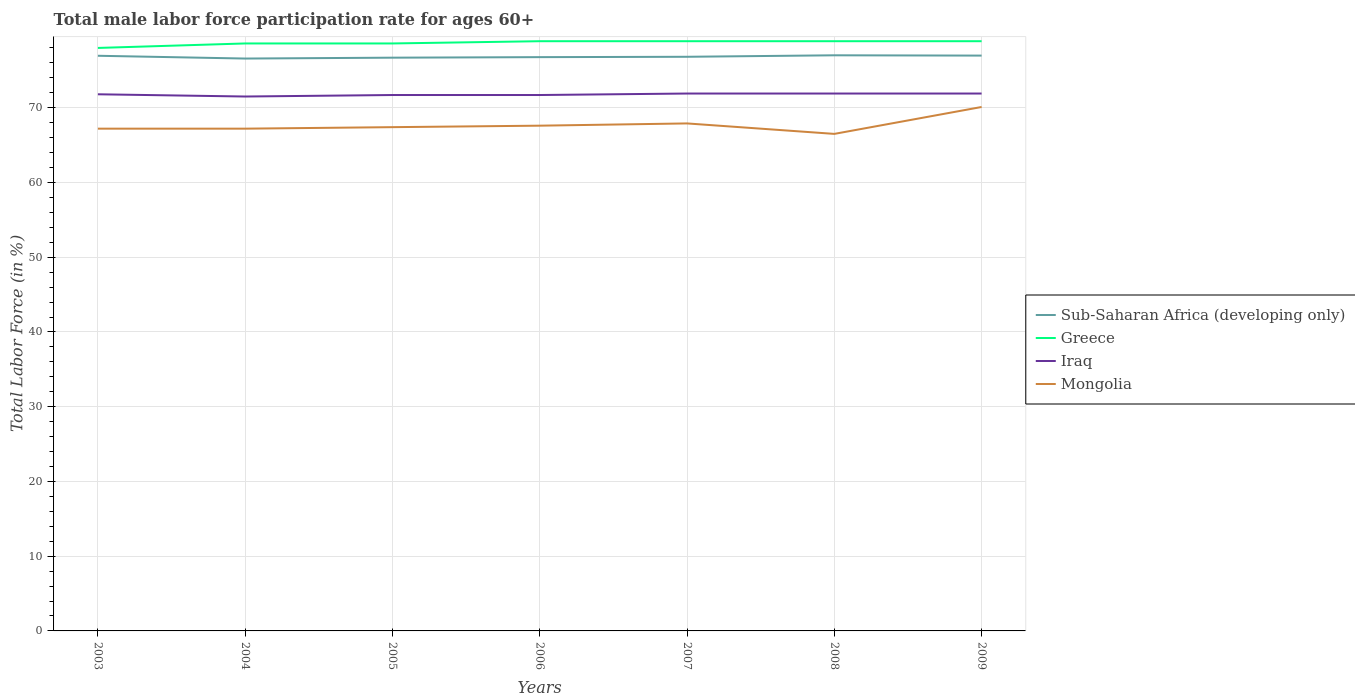How many different coloured lines are there?
Ensure brevity in your answer.  4. Is the number of lines equal to the number of legend labels?
Give a very brief answer. Yes. Across all years, what is the maximum male labor force participation rate in Greece?
Offer a terse response. 78. What is the difference between the highest and the second highest male labor force participation rate in Greece?
Your response must be concise. 0.9. How many lines are there?
Your response must be concise. 4. How many years are there in the graph?
Offer a very short reply. 7. Are the values on the major ticks of Y-axis written in scientific E-notation?
Provide a short and direct response. No. Where does the legend appear in the graph?
Offer a terse response. Center right. What is the title of the graph?
Give a very brief answer. Total male labor force participation rate for ages 60+. What is the label or title of the X-axis?
Give a very brief answer. Years. What is the Total Labor Force (in %) of Sub-Saharan Africa (developing only) in 2003?
Offer a terse response. 76.95. What is the Total Labor Force (in %) in Greece in 2003?
Your answer should be compact. 78. What is the Total Labor Force (in %) in Iraq in 2003?
Keep it short and to the point. 71.8. What is the Total Labor Force (in %) of Mongolia in 2003?
Ensure brevity in your answer.  67.2. What is the Total Labor Force (in %) of Sub-Saharan Africa (developing only) in 2004?
Your answer should be very brief. 76.58. What is the Total Labor Force (in %) of Greece in 2004?
Offer a very short reply. 78.6. What is the Total Labor Force (in %) in Iraq in 2004?
Ensure brevity in your answer.  71.5. What is the Total Labor Force (in %) in Mongolia in 2004?
Provide a succinct answer. 67.2. What is the Total Labor Force (in %) of Sub-Saharan Africa (developing only) in 2005?
Your answer should be very brief. 76.7. What is the Total Labor Force (in %) of Greece in 2005?
Your answer should be compact. 78.6. What is the Total Labor Force (in %) of Iraq in 2005?
Give a very brief answer. 71.7. What is the Total Labor Force (in %) in Mongolia in 2005?
Provide a short and direct response. 67.4. What is the Total Labor Force (in %) of Sub-Saharan Africa (developing only) in 2006?
Provide a short and direct response. 76.77. What is the Total Labor Force (in %) in Greece in 2006?
Your response must be concise. 78.9. What is the Total Labor Force (in %) of Iraq in 2006?
Your answer should be very brief. 71.7. What is the Total Labor Force (in %) in Mongolia in 2006?
Provide a short and direct response. 67.6. What is the Total Labor Force (in %) of Sub-Saharan Africa (developing only) in 2007?
Offer a very short reply. 76.82. What is the Total Labor Force (in %) in Greece in 2007?
Your response must be concise. 78.9. What is the Total Labor Force (in %) in Iraq in 2007?
Your answer should be compact. 71.9. What is the Total Labor Force (in %) in Mongolia in 2007?
Provide a short and direct response. 67.9. What is the Total Labor Force (in %) of Sub-Saharan Africa (developing only) in 2008?
Provide a succinct answer. 77.01. What is the Total Labor Force (in %) in Greece in 2008?
Ensure brevity in your answer.  78.9. What is the Total Labor Force (in %) of Iraq in 2008?
Ensure brevity in your answer.  71.9. What is the Total Labor Force (in %) in Mongolia in 2008?
Your answer should be very brief. 66.5. What is the Total Labor Force (in %) of Sub-Saharan Africa (developing only) in 2009?
Provide a succinct answer. 76.98. What is the Total Labor Force (in %) in Greece in 2009?
Keep it short and to the point. 78.9. What is the Total Labor Force (in %) of Iraq in 2009?
Offer a terse response. 71.9. What is the Total Labor Force (in %) of Mongolia in 2009?
Your response must be concise. 70.1. Across all years, what is the maximum Total Labor Force (in %) in Sub-Saharan Africa (developing only)?
Make the answer very short. 77.01. Across all years, what is the maximum Total Labor Force (in %) of Greece?
Your response must be concise. 78.9. Across all years, what is the maximum Total Labor Force (in %) in Iraq?
Your response must be concise. 71.9. Across all years, what is the maximum Total Labor Force (in %) in Mongolia?
Give a very brief answer. 70.1. Across all years, what is the minimum Total Labor Force (in %) of Sub-Saharan Africa (developing only)?
Provide a succinct answer. 76.58. Across all years, what is the minimum Total Labor Force (in %) in Iraq?
Your response must be concise. 71.5. Across all years, what is the minimum Total Labor Force (in %) of Mongolia?
Offer a terse response. 66.5. What is the total Total Labor Force (in %) in Sub-Saharan Africa (developing only) in the graph?
Your response must be concise. 537.81. What is the total Total Labor Force (in %) of Greece in the graph?
Your answer should be compact. 550.8. What is the total Total Labor Force (in %) in Iraq in the graph?
Provide a succinct answer. 502.4. What is the total Total Labor Force (in %) in Mongolia in the graph?
Provide a short and direct response. 473.9. What is the difference between the Total Labor Force (in %) in Sub-Saharan Africa (developing only) in 2003 and that in 2004?
Make the answer very short. 0.37. What is the difference between the Total Labor Force (in %) of Greece in 2003 and that in 2004?
Give a very brief answer. -0.6. What is the difference between the Total Labor Force (in %) of Iraq in 2003 and that in 2004?
Keep it short and to the point. 0.3. What is the difference between the Total Labor Force (in %) of Sub-Saharan Africa (developing only) in 2003 and that in 2005?
Provide a succinct answer. 0.26. What is the difference between the Total Labor Force (in %) of Iraq in 2003 and that in 2005?
Make the answer very short. 0.1. What is the difference between the Total Labor Force (in %) in Mongolia in 2003 and that in 2005?
Your answer should be very brief. -0.2. What is the difference between the Total Labor Force (in %) in Sub-Saharan Africa (developing only) in 2003 and that in 2006?
Ensure brevity in your answer.  0.18. What is the difference between the Total Labor Force (in %) in Iraq in 2003 and that in 2006?
Provide a succinct answer. 0.1. What is the difference between the Total Labor Force (in %) in Sub-Saharan Africa (developing only) in 2003 and that in 2007?
Provide a short and direct response. 0.14. What is the difference between the Total Labor Force (in %) in Greece in 2003 and that in 2007?
Your answer should be very brief. -0.9. What is the difference between the Total Labor Force (in %) in Sub-Saharan Africa (developing only) in 2003 and that in 2008?
Make the answer very short. -0.06. What is the difference between the Total Labor Force (in %) in Greece in 2003 and that in 2008?
Your answer should be compact. -0.9. What is the difference between the Total Labor Force (in %) in Iraq in 2003 and that in 2008?
Ensure brevity in your answer.  -0.1. What is the difference between the Total Labor Force (in %) in Mongolia in 2003 and that in 2008?
Offer a very short reply. 0.7. What is the difference between the Total Labor Force (in %) in Sub-Saharan Africa (developing only) in 2003 and that in 2009?
Your answer should be compact. -0.02. What is the difference between the Total Labor Force (in %) of Greece in 2003 and that in 2009?
Offer a terse response. -0.9. What is the difference between the Total Labor Force (in %) of Iraq in 2003 and that in 2009?
Give a very brief answer. -0.1. What is the difference between the Total Labor Force (in %) of Mongolia in 2003 and that in 2009?
Provide a succinct answer. -2.9. What is the difference between the Total Labor Force (in %) of Sub-Saharan Africa (developing only) in 2004 and that in 2005?
Give a very brief answer. -0.12. What is the difference between the Total Labor Force (in %) in Sub-Saharan Africa (developing only) in 2004 and that in 2006?
Offer a terse response. -0.19. What is the difference between the Total Labor Force (in %) of Mongolia in 2004 and that in 2006?
Give a very brief answer. -0.4. What is the difference between the Total Labor Force (in %) in Sub-Saharan Africa (developing only) in 2004 and that in 2007?
Offer a terse response. -0.23. What is the difference between the Total Labor Force (in %) in Greece in 2004 and that in 2007?
Offer a very short reply. -0.3. What is the difference between the Total Labor Force (in %) of Mongolia in 2004 and that in 2007?
Provide a short and direct response. -0.7. What is the difference between the Total Labor Force (in %) of Sub-Saharan Africa (developing only) in 2004 and that in 2008?
Your answer should be very brief. -0.43. What is the difference between the Total Labor Force (in %) of Greece in 2004 and that in 2008?
Make the answer very short. -0.3. What is the difference between the Total Labor Force (in %) of Iraq in 2004 and that in 2008?
Your answer should be compact. -0.4. What is the difference between the Total Labor Force (in %) of Mongolia in 2004 and that in 2008?
Your answer should be compact. 0.7. What is the difference between the Total Labor Force (in %) in Sub-Saharan Africa (developing only) in 2004 and that in 2009?
Your answer should be compact. -0.39. What is the difference between the Total Labor Force (in %) of Iraq in 2004 and that in 2009?
Offer a terse response. -0.4. What is the difference between the Total Labor Force (in %) of Mongolia in 2004 and that in 2009?
Give a very brief answer. -2.9. What is the difference between the Total Labor Force (in %) of Sub-Saharan Africa (developing only) in 2005 and that in 2006?
Keep it short and to the point. -0.07. What is the difference between the Total Labor Force (in %) in Greece in 2005 and that in 2006?
Your answer should be very brief. -0.3. What is the difference between the Total Labor Force (in %) in Iraq in 2005 and that in 2006?
Offer a very short reply. 0. What is the difference between the Total Labor Force (in %) in Sub-Saharan Africa (developing only) in 2005 and that in 2007?
Make the answer very short. -0.12. What is the difference between the Total Labor Force (in %) in Greece in 2005 and that in 2007?
Your answer should be very brief. -0.3. What is the difference between the Total Labor Force (in %) of Mongolia in 2005 and that in 2007?
Offer a terse response. -0.5. What is the difference between the Total Labor Force (in %) of Sub-Saharan Africa (developing only) in 2005 and that in 2008?
Offer a very short reply. -0.32. What is the difference between the Total Labor Force (in %) of Iraq in 2005 and that in 2008?
Make the answer very short. -0.2. What is the difference between the Total Labor Force (in %) in Sub-Saharan Africa (developing only) in 2005 and that in 2009?
Keep it short and to the point. -0.28. What is the difference between the Total Labor Force (in %) of Greece in 2005 and that in 2009?
Your response must be concise. -0.3. What is the difference between the Total Labor Force (in %) of Sub-Saharan Africa (developing only) in 2006 and that in 2007?
Keep it short and to the point. -0.05. What is the difference between the Total Labor Force (in %) of Greece in 2006 and that in 2007?
Provide a short and direct response. 0. What is the difference between the Total Labor Force (in %) of Iraq in 2006 and that in 2007?
Make the answer very short. -0.2. What is the difference between the Total Labor Force (in %) in Mongolia in 2006 and that in 2007?
Your answer should be very brief. -0.3. What is the difference between the Total Labor Force (in %) in Sub-Saharan Africa (developing only) in 2006 and that in 2008?
Offer a very short reply. -0.24. What is the difference between the Total Labor Force (in %) of Iraq in 2006 and that in 2008?
Offer a terse response. -0.2. What is the difference between the Total Labor Force (in %) in Mongolia in 2006 and that in 2008?
Make the answer very short. 1.1. What is the difference between the Total Labor Force (in %) of Sub-Saharan Africa (developing only) in 2006 and that in 2009?
Ensure brevity in your answer.  -0.21. What is the difference between the Total Labor Force (in %) of Iraq in 2006 and that in 2009?
Ensure brevity in your answer.  -0.2. What is the difference between the Total Labor Force (in %) of Sub-Saharan Africa (developing only) in 2007 and that in 2008?
Your answer should be very brief. -0.2. What is the difference between the Total Labor Force (in %) of Iraq in 2007 and that in 2008?
Offer a terse response. 0. What is the difference between the Total Labor Force (in %) in Sub-Saharan Africa (developing only) in 2007 and that in 2009?
Offer a very short reply. -0.16. What is the difference between the Total Labor Force (in %) in Greece in 2007 and that in 2009?
Keep it short and to the point. 0. What is the difference between the Total Labor Force (in %) of Mongolia in 2007 and that in 2009?
Offer a very short reply. -2.2. What is the difference between the Total Labor Force (in %) in Sub-Saharan Africa (developing only) in 2008 and that in 2009?
Keep it short and to the point. 0.04. What is the difference between the Total Labor Force (in %) of Greece in 2008 and that in 2009?
Your answer should be compact. 0. What is the difference between the Total Labor Force (in %) in Iraq in 2008 and that in 2009?
Offer a very short reply. 0. What is the difference between the Total Labor Force (in %) of Mongolia in 2008 and that in 2009?
Keep it short and to the point. -3.6. What is the difference between the Total Labor Force (in %) of Sub-Saharan Africa (developing only) in 2003 and the Total Labor Force (in %) of Greece in 2004?
Give a very brief answer. -1.65. What is the difference between the Total Labor Force (in %) of Sub-Saharan Africa (developing only) in 2003 and the Total Labor Force (in %) of Iraq in 2004?
Give a very brief answer. 5.45. What is the difference between the Total Labor Force (in %) in Sub-Saharan Africa (developing only) in 2003 and the Total Labor Force (in %) in Mongolia in 2004?
Your response must be concise. 9.75. What is the difference between the Total Labor Force (in %) of Greece in 2003 and the Total Labor Force (in %) of Mongolia in 2004?
Provide a succinct answer. 10.8. What is the difference between the Total Labor Force (in %) in Iraq in 2003 and the Total Labor Force (in %) in Mongolia in 2004?
Give a very brief answer. 4.6. What is the difference between the Total Labor Force (in %) in Sub-Saharan Africa (developing only) in 2003 and the Total Labor Force (in %) in Greece in 2005?
Your answer should be very brief. -1.65. What is the difference between the Total Labor Force (in %) in Sub-Saharan Africa (developing only) in 2003 and the Total Labor Force (in %) in Iraq in 2005?
Offer a terse response. 5.25. What is the difference between the Total Labor Force (in %) of Sub-Saharan Africa (developing only) in 2003 and the Total Labor Force (in %) of Mongolia in 2005?
Offer a very short reply. 9.55. What is the difference between the Total Labor Force (in %) in Greece in 2003 and the Total Labor Force (in %) in Iraq in 2005?
Offer a very short reply. 6.3. What is the difference between the Total Labor Force (in %) of Greece in 2003 and the Total Labor Force (in %) of Mongolia in 2005?
Give a very brief answer. 10.6. What is the difference between the Total Labor Force (in %) in Sub-Saharan Africa (developing only) in 2003 and the Total Labor Force (in %) in Greece in 2006?
Offer a very short reply. -1.95. What is the difference between the Total Labor Force (in %) in Sub-Saharan Africa (developing only) in 2003 and the Total Labor Force (in %) in Iraq in 2006?
Offer a terse response. 5.25. What is the difference between the Total Labor Force (in %) in Sub-Saharan Africa (developing only) in 2003 and the Total Labor Force (in %) in Mongolia in 2006?
Give a very brief answer. 9.35. What is the difference between the Total Labor Force (in %) in Greece in 2003 and the Total Labor Force (in %) in Iraq in 2006?
Keep it short and to the point. 6.3. What is the difference between the Total Labor Force (in %) in Sub-Saharan Africa (developing only) in 2003 and the Total Labor Force (in %) in Greece in 2007?
Offer a terse response. -1.95. What is the difference between the Total Labor Force (in %) of Sub-Saharan Africa (developing only) in 2003 and the Total Labor Force (in %) of Iraq in 2007?
Ensure brevity in your answer.  5.05. What is the difference between the Total Labor Force (in %) in Sub-Saharan Africa (developing only) in 2003 and the Total Labor Force (in %) in Mongolia in 2007?
Offer a terse response. 9.05. What is the difference between the Total Labor Force (in %) in Greece in 2003 and the Total Labor Force (in %) in Mongolia in 2007?
Give a very brief answer. 10.1. What is the difference between the Total Labor Force (in %) in Iraq in 2003 and the Total Labor Force (in %) in Mongolia in 2007?
Your answer should be compact. 3.9. What is the difference between the Total Labor Force (in %) in Sub-Saharan Africa (developing only) in 2003 and the Total Labor Force (in %) in Greece in 2008?
Keep it short and to the point. -1.95. What is the difference between the Total Labor Force (in %) in Sub-Saharan Africa (developing only) in 2003 and the Total Labor Force (in %) in Iraq in 2008?
Offer a very short reply. 5.05. What is the difference between the Total Labor Force (in %) in Sub-Saharan Africa (developing only) in 2003 and the Total Labor Force (in %) in Mongolia in 2008?
Your answer should be compact. 10.45. What is the difference between the Total Labor Force (in %) in Greece in 2003 and the Total Labor Force (in %) in Iraq in 2008?
Ensure brevity in your answer.  6.1. What is the difference between the Total Labor Force (in %) in Greece in 2003 and the Total Labor Force (in %) in Mongolia in 2008?
Ensure brevity in your answer.  11.5. What is the difference between the Total Labor Force (in %) of Iraq in 2003 and the Total Labor Force (in %) of Mongolia in 2008?
Offer a very short reply. 5.3. What is the difference between the Total Labor Force (in %) of Sub-Saharan Africa (developing only) in 2003 and the Total Labor Force (in %) of Greece in 2009?
Make the answer very short. -1.95. What is the difference between the Total Labor Force (in %) of Sub-Saharan Africa (developing only) in 2003 and the Total Labor Force (in %) of Iraq in 2009?
Your response must be concise. 5.05. What is the difference between the Total Labor Force (in %) in Sub-Saharan Africa (developing only) in 2003 and the Total Labor Force (in %) in Mongolia in 2009?
Your response must be concise. 6.85. What is the difference between the Total Labor Force (in %) of Greece in 2003 and the Total Labor Force (in %) of Iraq in 2009?
Give a very brief answer. 6.1. What is the difference between the Total Labor Force (in %) of Iraq in 2003 and the Total Labor Force (in %) of Mongolia in 2009?
Your answer should be compact. 1.7. What is the difference between the Total Labor Force (in %) of Sub-Saharan Africa (developing only) in 2004 and the Total Labor Force (in %) of Greece in 2005?
Offer a terse response. -2.02. What is the difference between the Total Labor Force (in %) in Sub-Saharan Africa (developing only) in 2004 and the Total Labor Force (in %) in Iraq in 2005?
Your answer should be very brief. 4.88. What is the difference between the Total Labor Force (in %) in Sub-Saharan Africa (developing only) in 2004 and the Total Labor Force (in %) in Mongolia in 2005?
Provide a short and direct response. 9.18. What is the difference between the Total Labor Force (in %) of Greece in 2004 and the Total Labor Force (in %) of Mongolia in 2005?
Provide a succinct answer. 11.2. What is the difference between the Total Labor Force (in %) in Iraq in 2004 and the Total Labor Force (in %) in Mongolia in 2005?
Provide a succinct answer. 4.1. What is the difference between the Total Labor Force (in %) in Sub-Saharan Africa (developing only) in 2004 and the Total Labor Force (in %) in Greece in 2006?
Keep it short and to the point. -2.32. What is the difference between the Total Labor Force (in %) in Sub-Saharan Africa (developing only) in 2004 and the Total Labor Force (in %) in Iraq in 2006?
Your answer should be very brief. 4.88. What is the difference between the Total Labor Force (in %) in Sub-Saharan Africa (developing only) in 2004 and the Total Labor Force (in %) in Mongolia in 2006?
Keep it short and to the point. 8.98. What is the difference between the Total Labor Force (in %) in Greece in 2004 and the Total Labor Force (in %) in Iraq in 2006?
Offer a terse response. 6.9. What is the difference between the Total Labor Force (in %) in Greece in 2004 and the Total Labor Force (in %) in Mongolia in 2006?
Your answer should be very brief. 11. What is the difference between the Total Labor Force (in %) in Iraq in 2004 and the Total Labor Force (in %) in Mongolia in 2006?
Offer a terse response. 3.9. What is the difference between the Total Labor Force (in %) in Sub-Saharan Africa (developing only) in 2004 and the Total Labor Force (in %) in Greece in 2007?
Your answer should be very brief. -2.32. What is the difference between the Total Labor Force (in %) of Sub-Saharan Africa (developing only) in 2004 and the Total Labor Force (in %) of Iraq in 2007?
Offer a terse response. 4.68. What is the difference between the Total Labor Force (in %) of Sub-Saharan Africa (developing only) in 2004 and the Total Labor Force (in %) of Mongolia in 2007?
Offer a terse response. 8.68. What is the difference between the Total Labor Force (in %) in Greece in 2004 and the Total Labor Force (in %) in Iraq in 2007?
Offer a terse response. 6.7. What is the difference between the Total Labor Force (in %) in Iraq in 2004 and the Total Labor Force (in %) in Mongolia in 2007?
Make the answer very short. 3.6. What is the difference between the Total Labor Force (in %) in Sub-Saharan Africa (developing only) in 2004 and the Total Labor Force (in %) in Greece in 2008?
Provide a short and direct response. -2.32. What is the difference between the Total Labor Force (in %) in Sub-Saharan Africa (developing only) in 2004 and the Total Labor Force (in %) in Iraq in 2008?
Provide a short and direct response. 4.68. What is the difference between the Total Labor Force (in %) in Sub-Saharan Africa (developing only) in 2004 and the Total Labor Force (in %) in Mongolia in 2008?
Give a very brief answer. 10.08. What is the difference between the Total Labor Force (in %) of Greece in 2004 and the Total Labor Force (in %) of Mongolia in 2008?
Offer a very short reply. 12.1. What is the difference between the Total Labor Force (in %) of Iraq in 2004 and the Total Labor Force (in %) of Mongolia in 2008?
Give a very brief answer. 5. What is the difference between the Total Labor Force (in %) of Sub-Saharan Africa (developing only) in 2004 and the Total Labor Force (in %) of Greece in 2009?
Offer a terse response. -2.32. What is the difference between the Total Labor Force (in %) of Sub-Saharan Africa (developing only) in 2004 and the Total Labor Force (in %) of Iraq in 2009?
Keep it short and to the point. 4.68. What is the difference between the Total Labor Force (in %) in Sub-Saharan Africa (developing only) in 2004 and the Total Labor Force (in %) in Mongolia in 2009?
Ensure brevity in your answer.  6.48. What is the difference between the Total Labor Force (in %) of Greece in 2004 and the Total Labor Force (in %) of Mongolia in 2009?
Offer a very short reply. 8.5. What is the difference between the Total Labor Force (in %) of Iraq in 2004 and the Total Labor Force (in %) of Mongolia in 2009?
Offer a terse response. 1.4. What is the difference between the Total Labor Force (in %) of Sub-Saharan Africa (developing only) in 2005 and the Total Labor Force (in %) of Greece in 2006?
Provide a short and direct response. -2.2. What is the difference between the Total Labor Force (in %) of Sub-Saharan Africa (developing only) in 2005 and the Total Labor Force (in %) of Iraq in 2006?
Provide a succinct answer. 5. What is the difference between the Total Labor Force (in %) of Sub-Saharan Africa (developing only) in 2005 and the Total Labor Force (in %) of Mongolia in 2006?
Your answer should be compact. 9.1. What is the difference between the Total Labor Force (in %) of Greece in 2005 and the Total Labor Force (in %) of Mongolia in 2006?
Your response must be concise. 11. What is the difference between the Total Labor Force (in %) of Iraq in 2005 and the Total Labor Force (in %) of Mongolia in 2006?
Your answer should be very brief. 4.1. What is the difference between the Total Labor Force (in %) in Sub-Saharan Africa (developing only) in 2005 and the Total Labor Force (in %) in Greece in 2007?
Make the answer very short. -2.2. What is the difference between the Total Labor Force (in %) in Sub-Saharan Africa (developing only) in 2005 and the Total Labor Force (in %) in Iraq in 2007?
Your response must be concise. 4.8. What is the difference between the Total Labor Force (in %) in Sub-Saharan Africa (developing only) in 2005 and the Total Labor Force (in %) in Mongolia in 2007?
Keep it short and to the point. 8.8. What is the difference between the Total Labor Force (in %) of Greece in 2005 and the Total Labor Force (in %) of Iraq in 2007?
Keep it short and to the point. 6.7. What is the difference between the Total Labor Force (in %) in Greece in 2005 and the Total Labor Force (in %) in Mongolia in 2007?
Your answer should be very brief. 10.7. What is the difference between the Total Labor Force (in %) of Iraq in 2005 and the Total Labor Force (in %) of Mongolia in 2007?
Make the answer very short. 3.8. What is the difference between the Total Labor Force (in %) of Sub-Saharan Africa (developing only) in 2005 and the Total Labor Force (in %) of Greece in 2008?
Make the answer very short. -2.2. What is the difference between the Total Labor Force (in %) in Sub-Saharan Africa (developing only) in 2005 and the Total Labor Force (in %) in Iraq in 2008?
Provide a short and direct response. 4.8. What is the difference between the Total Labor Force (in %) of Sub-Saharan Africa (developing only) in 2005 and the Total Labor Force (in %) of Mongolia in 2008?
Offer a terse response. 10.2. What is the difference between the Total Labor Force (in %) of Greece in 2005 and the Total Labor Force (in %) of Mongolia in 2008?
Make the answer very short. 12.1. What is the difference between the Total Labor Force (in %) of Sub-Saharan Africa (developing only) in 2005 and the Total Labor Force (in %) of Greece in 2009?
Your answer should be compact. -2.2. What is the difference between the Total Labor Force (in %) in Sub-Saharan Africa (developing only) in 2005 and the Total Labor Force (in %) in Iraq in 2009?
Your response must be concise. 4.8. What is the difference between the Total Labor Force (in %) in Sub-Saharan Africa (developing only) in 2005 and the Total Labor Force (in %) in Mongolia in 2009?
Offer a very short reply. 6.6. What is the difference between the Total Labor Force (in %) of Greece in 2005 and the Total Labor Force (in %) of Mongolia in 2009?
Ensure brevity in your answer.  8.5. What is the difference between the Total Labor Force (in %) in Sub-Saharan Africa (developing only) in 2006 and the Total Labor Force (in %) in Greece in 2007?
Your response must be concise. -2.13. What is the difference between the Total Labor Force (in %) in Sub-Saharan Africa (developing only) in 2006 and the Total Labor Force (in %) in Iraq in 2007?
Make the answer very short. 4.87. What is the difference between the Total Labor Force (in %) of Sub-Saharan Africa (developing only) in 2006 and the Total Labor Force (in %) of Mongolia in 2007?
Offer a terse response. 8.87. What is the difference between the Total Labor Force (in %) in Greece in 2006 and the Total Labor Force (in %) in Iraq in 2007?
Keep it short and to the point. 7. What is the difference between the Total Labor Force (in %) of Greece in 2006 and the Total Labor Force (in %) of Mongolia in 2007?
Provide a succinct answer. 11. What is the difference between the Total Labor Force (in %) of Sub-Saharan Africa (developing only) in 2006 and the Total Labor Force (in %) of Greece in 2008?
Provide a short and direct response. -2.13. What is the difference between the Total Labor Force (in %) in Sub-Saharan Africa (developing only) in 2006 and the Total Labor Force (in %) in Iraq in 2008?
Ensure brevity in your answer.  4.87. What is the difference between the Total Labor Force (in %) of Sub-Saharan Africa (developing only) in 2006 and the Total Labor Force (in %) of Mongolia in 2008?
Keep it short and to the point. 10.27. What is the difference between the Total Labor Force (in %) of Sub-Saharan Africa (developing only) in 2006 and the Total Labor Force (in %) of Greece in 2009?
Your answer should be very brief. -2.13. What is the difference between the Total Labor Force (in %) in Sub-Saharan Africa (developing only) in 2006 and the Total Labor Force (in %) in Iraq in 2009?
Keep it short and to the point. 4.87. What is the difference between the Total Labor Force (in %) of Sub-Saharan Africa (developing only) in 2006 and the Total Labor Force (in %) of Mongolia in 2009?
Offer a very short reply. 6.67. What is the difference between the Total Labor Force (in %) in Greece in 2006 and the Total Labor Force (in %) in Mongolia in 2009?
Make the answer very short. 8.8. What is the difference between the Total Labor Force (in %) of Iraq in 2006 and the Total Labor Force (in %) of Mongolia in 2009?
Provide a short and direct response. 1.6. What is the difference between the Total Labor Force (in %) in Sub-Saharan Africa (developing only) in 2007 and the Total Labor Force (in %) in Greece in 2008?
Offer a terse response. -2.08. What is the difference between the Total Labor Force (in %) of Sub-Saharan Africa (developing only) in 2007 and the Total Labor Force (in %) of Iraq in 2008?
Make the answer very short. 4.92. What is the difference between the Total Labor Force (in %) of Sub-Saharan Africa (developing only) in 2007 and the Total Labor Force (in %) of Mongolia in 2008?
Your response must be concise. 10.32. What is the difference between the Total Labor Force (in %) of Greece in 2007 and the Total Labor Force (in %) of Mongolia in 2008?
Your answer should be very brief. 12.4. What is the difference between the Total Labor Force (in %) of Sub-Saharan Africa (developing only) in 2007 and the Total Labor Force (in %) of Greece in 2009?
Provide a short and direct response. -2.08. What is the difference between the Total Labor Force (in %) in Sub-Saharan Africa (developing only) in 2007 and the Total Labor Force (in %) in Iraq in 2009?
Make the answer very short. 4.92. What is the difference between the Total Labor Force (in %) in Sub-Saharan Africa (developing only) in 2007 and the Total Labor Force (in %) in Mongolia in 2009?
Give a very brief answer. 6.72. What is the difference between the Total Labor Force (in %) in Greece in 2007 and the Total Labor Force (in %) in Iraq in 2009?
Keep it short and to the point. 7. What is the difference between the Total Labor Force (in %) of Iraq in 2007 and the Total Labor Force (in %) of Mongolia in 2009?
Your answer should be very brief. 1.8. What is the difference between the Total Labor Force (in %) in Sub-Saharan Africa (developing only) in 2008 and the Total Labor Force (in %) in Greece in 2009?
Provide a short and direct response. -1.89. What is the difference between the Total Labor Force (in %) in Sub-Saharan Africa (developing only) in 2008 and the Total Labor Force (in %) in Iraq in 2009?
Keep it short and to the point. 5.11. What is the difference between the Total Labor Force (in %) of Sub-Saharan Africa (developing only) in 2008 and the Total Labor Force (in %) of Mongolia in 2009?
Your answer should be very brief. 6.91. What is the difference between the Total Labor Force (in %) of Greece in 2008 and the Total Labor Force (in %) of Iraq in 2009?
Your answer should be very brief. 7. What is the average Total Labor Force (in %) of Sub-Saharan Africa (developing only) per year?
Your answer should be compact. 76.83. What is the average Total Labor Force (in %) in Greece per year?
Provide a succinct answer. 78.69. What is the average Total Labor Force (in %) of Iraq per year?
Your response must be concise. 71.77. What is the average Total Labor Force (in %) in Mongolia per year?
Give a very brief answer. 67.7. In the year 2003, what is the difference between the Total Labor Force (in %) of Sub-Saharan Africa (developing only) and Total Labor Force (in %) of Greece?
Offer a very short reply. -1.05. In the year 2003, what is the difference between the Total Labor Force (in %) of Sub-Saharan Africa (developing only) and Total Labor Force (in %) of Iraq?
Your response must be concise. 5.15. In the year 2003, what is the difference between the Total Labor Force (in %) in Sub-Saharan Africa (developing only) and Total Labor Force (in %) in Mongolia?
Your answer should be compact. 9.75. In the year 2003, what is the difference between the Total Labor Force (in %) of Greece and Total Labor Force (in %) of Mongolia?
Your answer should be very brief. 10.8. In the year 2004, what is the difference between the Total Labor Force (in %) of Sub-Saharan Africa (developing only) and Total Labor Force (in %) of Greece?
Your response must be concise. -2.02. In the year 2004, what is the difference between the Total Labor Force (in %) in Sub-Saharan Africa (developing only) and Total Labor Force (in %) in Iraq?
Make the answer very short. 5.08. In the year 2004, what is the difference between the Total Labor Force (in %) of Sub-Saharan Africa (developing only) and Total Labor Force (in %) of Mongolia?
Your response must be concise. 9.38. In the year 2004, what is the difference between the Total Labor Force (in %) in Greece and Total Labor Force (in %) in Mongolia?
Give a very brief answer. 11.4. In the year 2004, what is the difference between the Total Labor Force (in %) in Iraq and Total Labor Force (in %) in Mongolia?
Keep it short and to the point. 4.3. In the year 2005, what is the difference between the Total Labor Force (in %) in Sub-Saharan Africa (developing only) and Total Labor Force (in %) in Greece?
Provide a short and direct response. -1.9. In the year 2005, what is the difference between the Total Labor Force (in %) of Sub-Saharan Africa (developing only) and Total Labor Force (in %) of Iraq?
Give a very brief answer. 5. In the year 2005, what is the difference between the Total Labor Force (in %) of Sub-Saharan Africa (developing only) and Total Labor Force (in %) of Mongolia?
Ensure brevity in your answer.  9.3. In the year 2005, what is the difference between the Total Labor Force (in %) of Greece and Total Labor Force (in %) of Mongolia?
Your response must be concise. 11.2. In the year 2006, what is the difference between the Total Labor Force (in %) of Sub-Saharan Africa (developing only) and Total Labor Force (in %) of Greece?
Provide a short and direct response. -2.13. In the year 2006, what is the difference between the Total Labor Force (in %) of Sub-Saharan Africa (developing only) and Total Labor Force (in %) of Iraq?
Offer a very short reply. 5.07. In the year 2006, what is the difference between the Total Labor Force (in %) in Sub-Saharan Africa (developing only) and Total Labor Force (in %) in Mongolia?
Your answer should be compact. 9.17. In the year 2006, what is the difference between the Total Labor Force (in %) of Iraq and Total Labor Force (in %) of Mongolia?
Offer a terse response. 4.1. In the year 2007, what is the difference between the Total Labor Force (in %) of Sub-Saharan Africa (developing only) and Total Labor Force (in %) of Greece?
Your answer should be compact. -2.08. In the year 2007, what is the difference between the Total Labor Force (in %) in Sub-Saharan Africa (developing only) and Total Labor Force (in %) in Iraq?
Provide a succinct answer. 4.92. In the year 2007, what is the difference between the Total Labor Force (in %) of Sub-Saharan Africa (developing only) and Total Labor Force (in %) of Mongolia?
Your response must be concise. 8.92. In the year 2007, what is the difference between the Total Labor Force (in %) in Greece and Total Labor Force (in %) in Iraq?
Ensure brevity in your answer.  7. In the year 2007, what is the difference between the Total Labor Force (in %) in Greece and Total Labor Force (in %) in Mongolia?
Ensure brevity in your answer.  11. In the year 2007, what is the difference between the Total Labor Force (in %) of Iraq and Total Labor Force (in %) of Mongolia?
Offer a terse response. 4. In the year 2008, what is the difference between the Total Labor Force (in %) of Sub-Saharan Africa (developing only) and Total Labor Force (in %) of Greece?
Provide a succinct answer. -1.89. In the year 2008, what is the difference between the Total Labor Force (in %) in Sub-Saharan Africa (developing only) and Total Labor Force (in %) in Iraq?
Your answer should be compact. 5.11. In the year 2008, what is the difference between the Total Labor Force (in %) in Sub-Saharan Africa (developing only) and Total Labor Force (in %) in Mongolia?
Your answer should be compact. 10.51. In the year 2009, what is the difference between the Total Labor Force (in %) of Sub-Saharan Africa (developing only) and Total Labor Force (in %) of Greece?
Your response must be concise. -1.92. In the year 2009, what is the difference between the Total Labor Force (in %) in Sub-Saharan Africa (developing only) and Total Labor Force (in %) in Iraq?
Make the answer very short. 5.08. In the year 2009, what is the difference between the Total Labor Force (in %) in Sub-Saharan Africa (developing only) and Total Labor Force (in %) in Mongolia?
Ensure brevity in your answer.  6.88. In the year 2009, what is the difference between the Total Labor Force (in %) in Greece and Total Labor Force (in %) in Iraq?
Make the answer very short. 7. In the year 2009, what is the difference between the Total Labor Force (in %) in Iraq and Total Labor Force (in %) in Mongolia?
Offer a very short reply. 1.8. What is the ratio of the Total Labor Force (in %) of Greece in 2003 to that in 2004?
Provide a succinct answer. 0.99. What is the ratio of the Total Labor Force (in %) of Sub-Saharan Africa (developing only) in 2003 to that in 2005?
Keep it short and to the point. 1. What is the ratio of the Total Labor Force (in %) of Greece in 2003 to that in 2005?
Keep it short and to the point. 0.99. What is the ratio of the Total Labor Force (in %) in Iraq in 2003 to that in 2005?
Offer a very short reply. 1. What is the ratio of the Total Labor Force (in %) of Greece in 2003 to that in 2006?
Offer a very short reply. 0.99. What is the ratio of the Total Labor Force (in %) of Iraq in 2003 to that in 2006?
Keep it short and to the point. 1. What is the ratio of the Total Labor Force (in %) of Sub-Saharan Africa (developing only) in 2003 to that in 2007?
Make the answer very short. 1. What is the ratio of the Total Labor Force (in %) of Greece in 2003 to that in 2007?
Make the answer very short. 0.99. What is the ratio of the Total Labor Force (in %) in Iraq in 2003 to that in 2007?
Your answer should be very brief. 1. What is the ratio of the Total Labor Force (in %) of Mongolia in 2003 to that in 2007?
Provide a short and direct response. 0.99. What is the ratio of the Total Labor Force (in %) of Sub-Saharan Africa (developing only) in 2003 to that in 2008?
Offer a very short reply. 1. What is the ratio of the Total Labor Force (in %) of Greece in 2003 to that in 2008?
Keep it short and to the point. 0.99. What is the ratio of the Total Labor Force (in %) in Iraq in 2003 to that in 2008?
Provide a succinct answer. 1. What is the ratio of the Total Labor Force (in %) of Mongolia in 2003 to that in 2008?
Give a very brief answer. 1.01. What is the ratio of the Total Labor Force (in %) of Sub-Saharan Africa (developing only) in 2003 to that in 2009?
Ensure brevity in your answer.  1. What is the ratio of the Total Labor Force (in %) of Greece in 2003 to that in 2009?
Your response must be concise. 0.99. What is the ratio of the Total Labor Force (in %) of Mongolia in 2003 to that in 2009?
Provide a succinct answer. 0.96. What is the ratio of the Total Labor Force (in %) in Sub-Saharan Africa (developing only) in 2004 to that in 2005?
Your answer should be compact. 1. What is the ratio of the Total Labor Force (in %) in Greece in 2004 to that in 2005?
Keep it short and to the point. 1. What is the ratio of the Total Labor Force (in %) in Mongolia in 2004 to that in 2005?
Keep it short and to the point. 1. What is the ratio of the Total Labor Force (in %) of Sub-Saharan Africa (developing only) in 2004 to that in 2006?
Your answer should be compact. 1. What is the ratio of the Total Labor Force (in %) in Greece in 2004 to that in 2006?
Your answer should be compact. 1. What is the ratio of the Total Labor Force (in %) in Iraq in 2004 to that in 2006?
Offer a terse response. 1. What is the ratio of the Total Labor Force (in %) in Greece in 2004 to that in 2007?
Offer a terse response. 1. What is the ratio of the Total Labor Force (in %) of Sub-Saharan Africa (developing only) in 2004 to that in 2008?
Ensure brevity in your answer.  0.99. What is the ratio of the Total Labor Force (in %) in Greece in 2004 to that in 2008?
Offer a very short reply. 1. What is the ratio of the Total Labor Force (in %) of Iraq in 2004 to that in 2008?
Your answer should be compact. 0.99. What is the ratio of the Total Labor Force (in %) in Mongolia in 2004 to that in 2008?
Provide a succinct answer. 1.01. What is the ratio of the Total Labor Force (in %) of Greece in 2004 to that in 2009?
Ensure brevity in your answer.  1. What is the ratio of the Total Labor Force (in %) of Mongolia in 2004 to that in 2009?
Offer a very short reply. 0.96. What is the ratio of the Total Labor Force (in %) of Sub-Saharan Africa (developing only) in 2005 to that in 2006?
Your response must be concise. 1. What is the ratio of the Total Labor Force (in %) in Greece in 2005 to that in 2006?
Ensure brevity in your answer.  1. What is the ratio of the Total Labor Force (in %) in Mongolia in 2005 to that in 2006?
Your response must be concise. 1. What is the ratio of the Total Labor Force (in %) in Sub-Saharan Africa (developing only) in 2005 to that in 2007?
Give a very brief answer. 1. What is the ratio of the Total Labor Force (in %) in Greece in 2005 to that in 2007?
Keep it short and to the point. 1. What is the ratio of the Total Labor Force (in %) of Iraq in 2005 to that in 2007?
Your response must be concise. 1. What is the ratio of the Total Labor Force (in %) in Mongolia in 2005 to that in 2007?
Provide a short and direct response. 0.99. What is the ratio of the Total Labor Force (in %) of Sub-Saharan Africa (developing only) in 2005 to that in 2008?
Make the answer very short. 1. What is the ratio of the Total Labor Force (in %) of Greece in 2005 to that in 2008?
Keep it short and to the point. 1. What is the ratio of the Total Labor Force (in %) of Iraq in 2005 to that in 2008?
Give a very brief answer. 1. What is the ratio of the Total Labor Force (in %) in Mongolia in 2005 to that in 2008?
Keep it short and to the point. 1.01. What is the ratio of the Total Labor Force (in %) of Greece in 2005 to that in 2009?
Offer a very short reply. 1. What is the ratio of the Total Labor Force (in %) of Mongolia in 2005 to that in 2009?
Make the answer very short. 0.96. What is the ratio of the Total Labor Force (in %) in Greece in 2006 to that in 2007?
Your answer should be very brief. 1. What is the ratio of the Total Labor Force (in %) in Mongolia in 2006 to that in 2007?
Ensure brevity in your answer.  1. What is the ratio of the Total Labor Force (in %) of Sub-Saharan Africa (developing only) in 2006 to that in 2008?
Your answer should be compact. 1. What is the ratio of the Total Labor Force (in %) of Greece in 2006 to that in 2008?
Provide a succinct answer. 1. What is the ratio of the Total Labor Force (in %) of Iraq in 2006 to that in 2008?
Keep it short and to the point. 1. What is the ratio of the Total Labor Force (in %) in Mongolia in 2006 to that in 2008?
Make the answer very short. 1.02. What is the ratio of the Total Labor Force (in %) of Iraq in 2006 to that in 2009?
Your response must be concise. 1. What is the ratio of the Total Labor Force (in %) of Mongolia in 2006 to that in 2009?
Make the answer very short. 0.96. What is the ratio of the Total Labor Force (in %) of Sub-Saharan Africa (developing only) in 2007 to that in 2008?
Offer a terse response. 1. What is the ratio of the Total Labor Force (in %) in Greece in 2007 to that in 2008?
Ensure brevity in your answer.  1. What is the ratio of the Total Labor Force (in %) of Iraq in 2007 to that in 2008?
Offer a terse response. 1. What is the ratio of the Total Labor Force (in %) in Mongolia in 2007 to that in 2008?
Give a very brief answer. 1.02. What is the ratio of the Total Labor Force (in %) in Sub-Saharan Africa (developing only) in 2007 to that in 2009?
Your answer should be very brief. 1. What is the ratio of the Total Labor Force (in %) in Greece in 2007 to that in 2009?
Your answer should be compact. 1. What is the ratio of the Total Labor Force (in %) in Mongolia in 2007 to that in 2009?
Provide a short and direct response. 0.97. What is the ratio of the Total Labor Force (in %) of Iraq in 2008 to that in 2009?
Offer a terse response. 1. What is the ratio of the Total Labor Force (in %) in Mongolia in 2008 to that in 2009?
Give a very brief answer. 0.95. What is the difference between the highest and the second highest Total Labor Force (in %) in Sub-Saharan Africa (developing only)?
Provide a short and direct response. 0.04. What is the difference between the highest and the second highest Total Labor Force (in %) in Greece?
Offer a very short reply. 0. What is the difference between the highest and the second highest Total Labor Force (in %) of Iraq?
Your response must be concise. 0. What is the difference between the highest and the lowest Total Labor Force (in %) of Sub-Saharan Africa (developing only)?
Your answer should be very brief. 0.43. What is the difference between the highest and the lowest Total Labor Force (in %) of Greece?
Give a very brief answer. 0.9. What is the difference between the highest and the lowest Total Labor Force (in %) in Iraq?
Your answer should be compact. 0.4. 